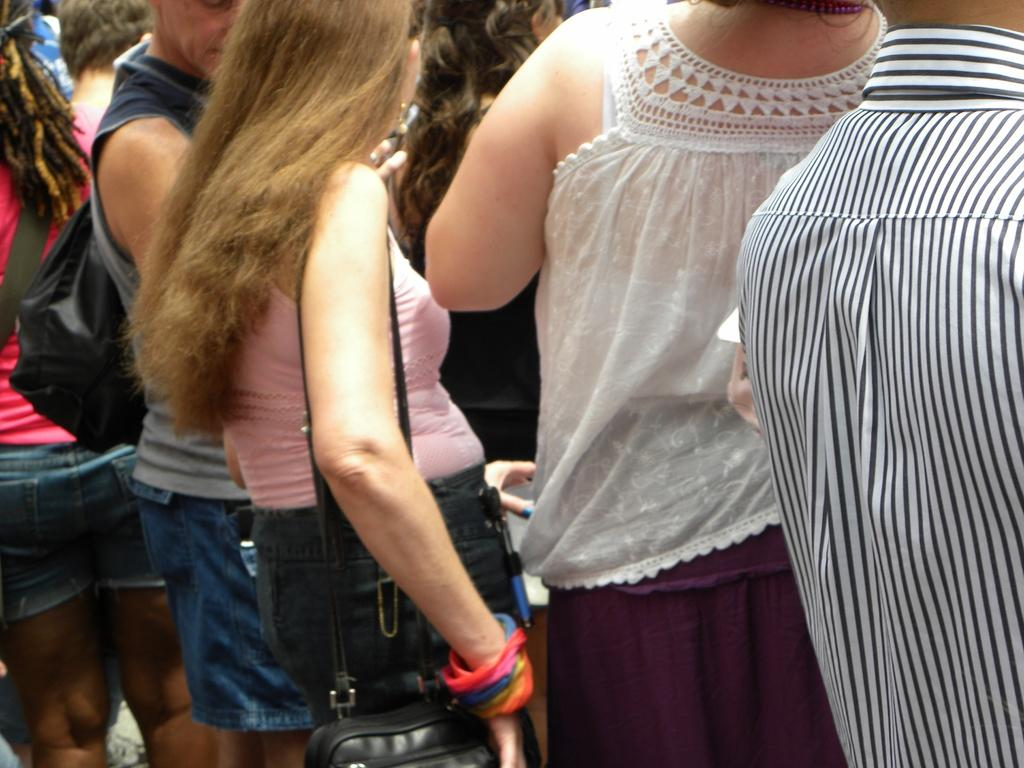How many people are in the group shown in the image? There is a group of people in the image, but the exact number is not specified. What are some people in the group wearing? Some people in the group are wearing bags. What is the woman in the image holding? A woman is holding an object in the image, but the specific object is not described. What type of button is being pushed by the tank in the image? There is no button or tank present in the image. What is the weight of the object being held by the woman in the image? The specific object being held by the woman is not described, so we cannot determine its weight. 